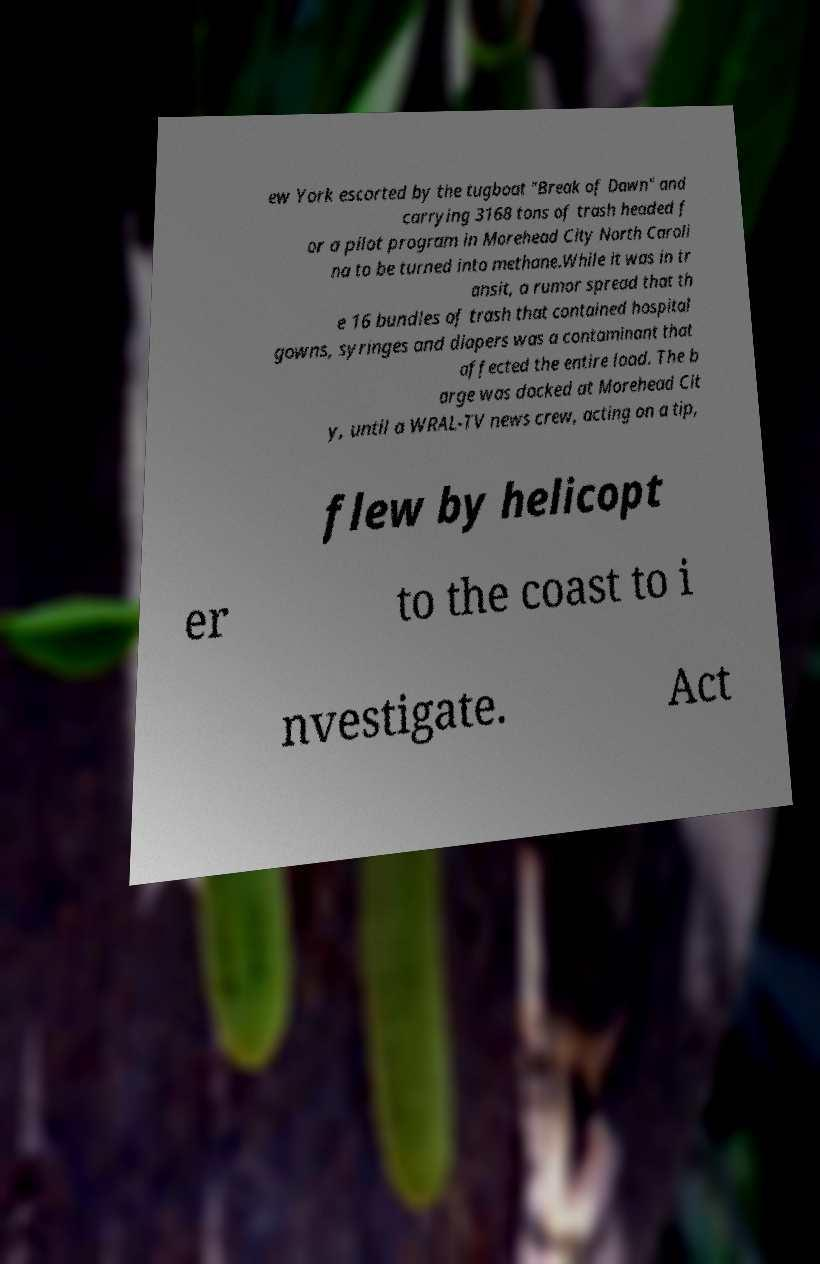Please read and relay the text visible in this image. What does it say? ew York escorted by the tugboat "Break of Dawn" and carrying 3168 tons of trash headed f or a pilot program in Morehead City North Caroli na to be turned into methane.While it was in tr ansit, a rumor spread that th e 16 bundles of trash that contained hospital gowns, syringes and diapers was a contaminant that affected the entire load. The b arge was docked at Morehead Cit y, until a WRAL-TV news crew, acting on a tip, flew by helicopt er to the coast to i nvestigate. Act 